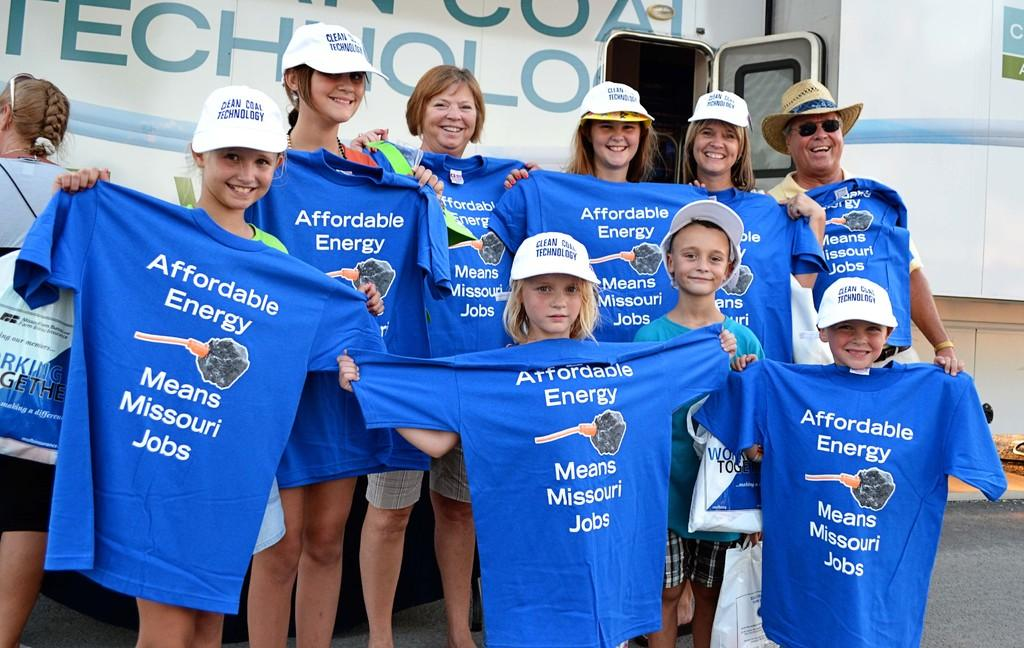<image>
Present a compact description of the photo's key features. A group of people each holding up blue shirts emblazoned with Affordable Energy Means Missouri Jobs. 